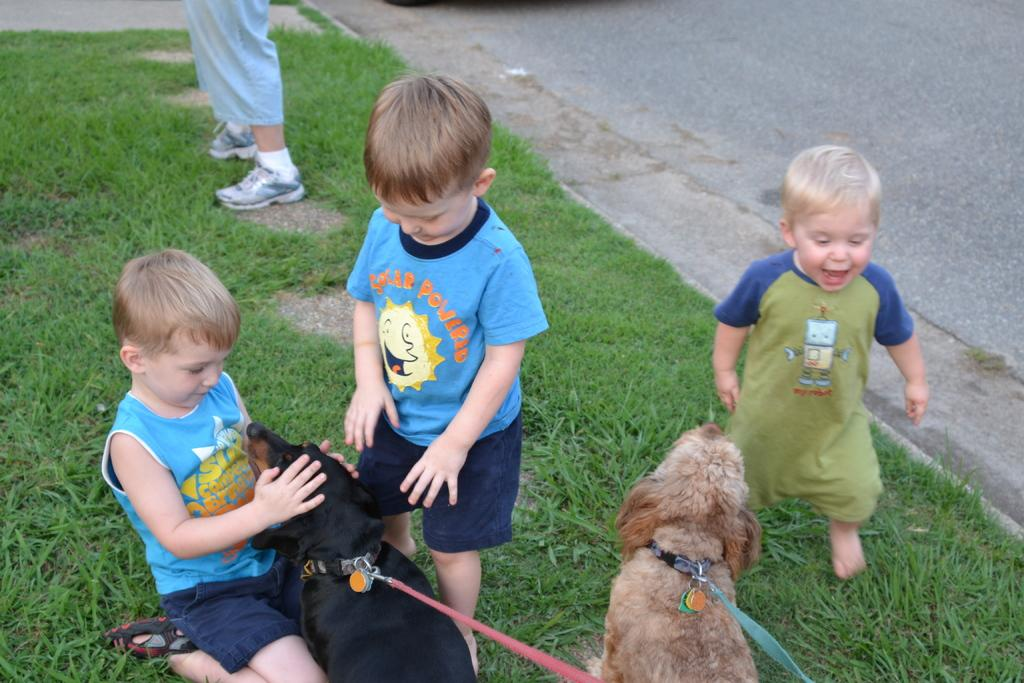How many dogs are present in the image? There are 2 dogs in the image. How many people are present in the image? There are 4 people in the image. Where are the people located in the image? The people are on the grass. What can be seen on the right side of the image? There is a road on the right side of the image. What type of honey is being collected by the dogs in the image? There is no honey or honey collection activity present in the image; it features 2 dogs and 4 people on the grass. 